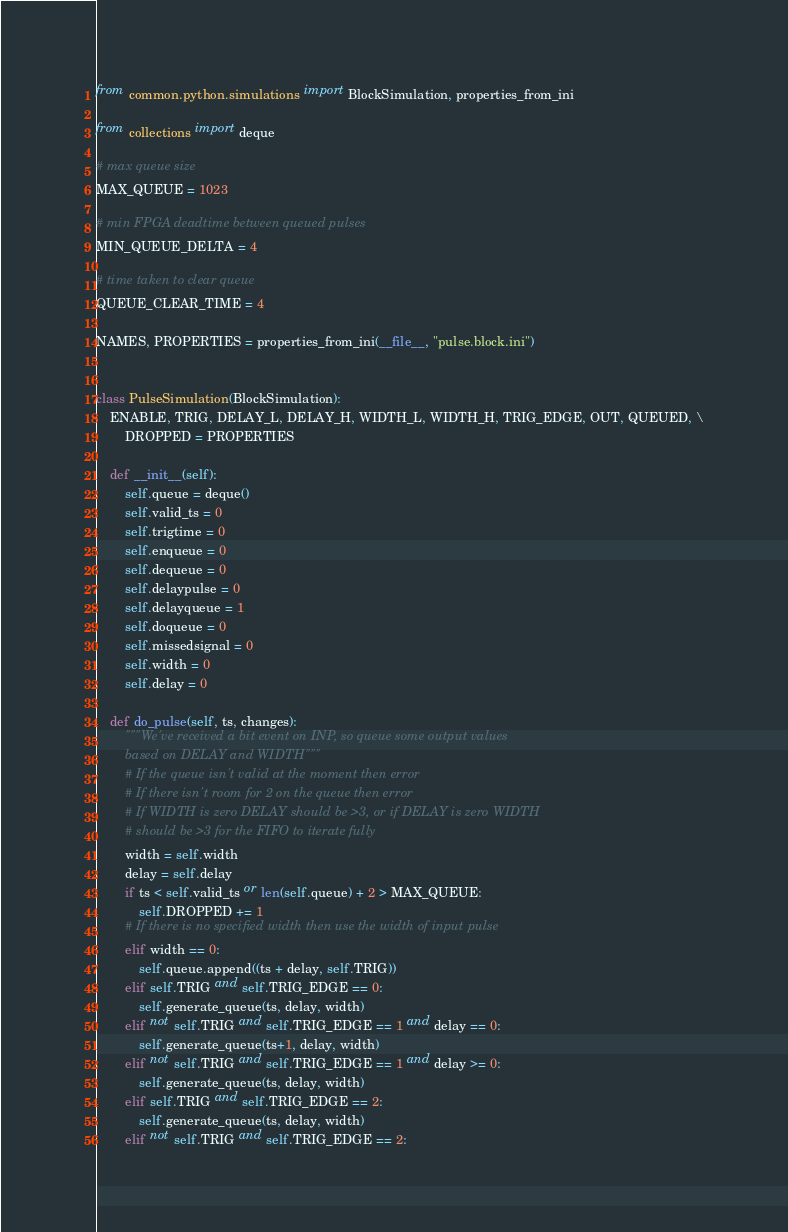Convert code to text. <code><loc_0><loc_0><loc_500><loc_500><_Python_>from common.python.simulations import BlockSimulation, properties_from_ini

from collections import deque

# max queue size
MAX_QUEUE = 1023

# min FPGA deadtime between queued pulses
MIN_QUEUE_DELTA = 4

# time taken to clear queue
QUEUE_CLEAR_TIME = 4

NAMES, PROPERTIES = properties_from_ini(__file__, "pulse.block.ini")


class PulseSimulation(BlockSimulation):
    ENABLE, TRIG, DELAY_L, DELAY_H, WIDTH_L, WIDTH_H, TRIG_EDGE, OUT, QUEUED, \
        DROPPED = PROPERTIES

    def __init__(self):
        self.queue = deque()
        self.valid_ts = 0
        self.trigtime = 0
        self.enqueue = 0
        self.dequeue = 0
        self.delaypulse = 0
        self.delayqueue = 1
        self.doqueue = 0
        self.missedsignal = 0
        self.width = 0
        self.delay = 0

    def do_pulse(self, ts, changes):
        """We've received a bit event on INP, so queue some output values
        based on DELAY and WIDTH"""
        # If the queue isn't valid at the moment then error
        # If there isn't room for 2 on the queue then error
        # If WIDTH is zero DELAY should be >3, or if DELAY is zero WIDTH
        # should be >3 for the FIFO to iterate fully
        width = self.width
        delay = self.delay
        if ts < self.valid_ts or len(self.queue) + 2 > MAX_QUEUE:
            self.DROPPED += 1
        # If there is no specified width then use the width of input pulse
        elif width == 0:
            self.queue.append((ts + delay, self.TRIG))
        elif self.TRIG and self.TRIG_EDGE == 0:
            self.generate_queue(ts, delay, width)
        elif not self.TRIG and self.TRIG_EDGE == 1 and delay == 0:
            self.generate_queue(ts+1, delay, width)
        elif not self.TRIG and self.TRIG_EDGE == 1 and delay >= 0:
            self.generate_queue(ts, delay, width)
        elif self.TRIG and self.TRIG_EDGE == 2:
            self.generate_queue(ts, delay, width)
        elif not self.TRIG and self.TRIG_EDGE == 2:</code> 